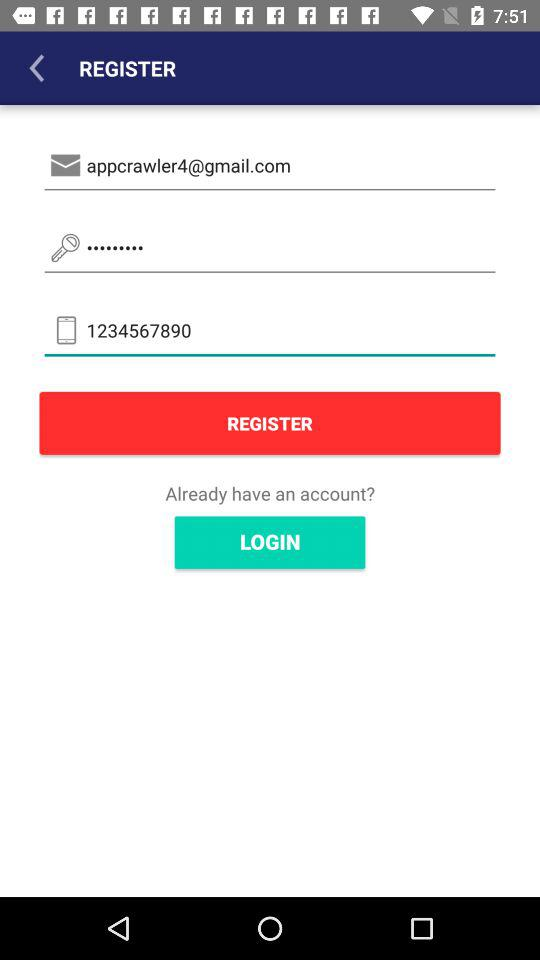What is the email address of the user? The email address is appcrawler4@gmail.com. 